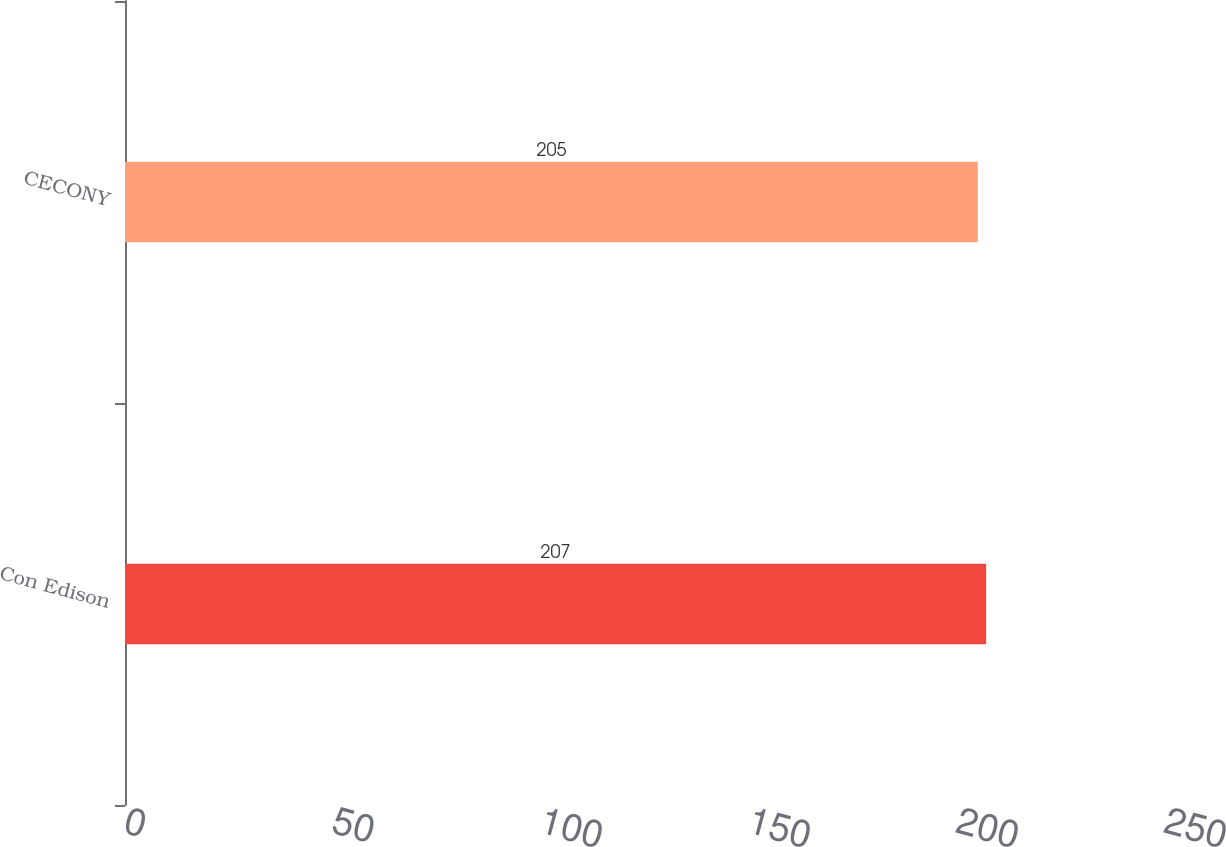Convert chart. <chart><loc_0><loc_0><loc_500><loc_500><bar_chart><fcel>Con Edison<fcel>CECONY<nl><fcel>207<fcel>205<nl></chart> 